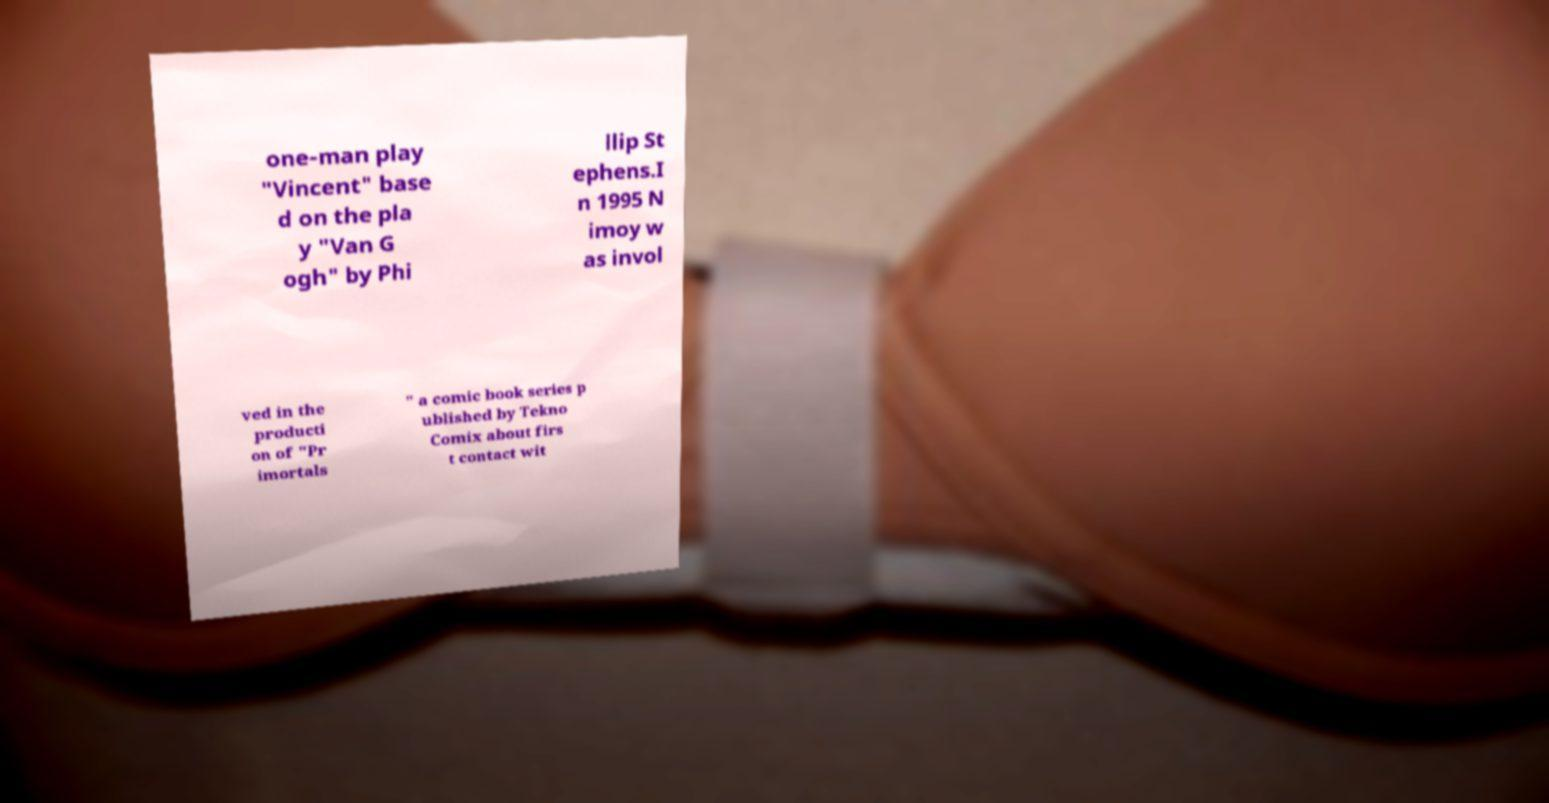Can you read and provide the text displayed in the image?This photo seems to have some interesting text. Can you extract and type it out for me? one-man play "Vincent" base d on the pla y "Van G ogh" by Phi llip St ephens.I n 1995 N imoy w as invol ved in the producti on of "Pr imortals " a comic book series p ublished by Tekno Comix about firs t contact wit 